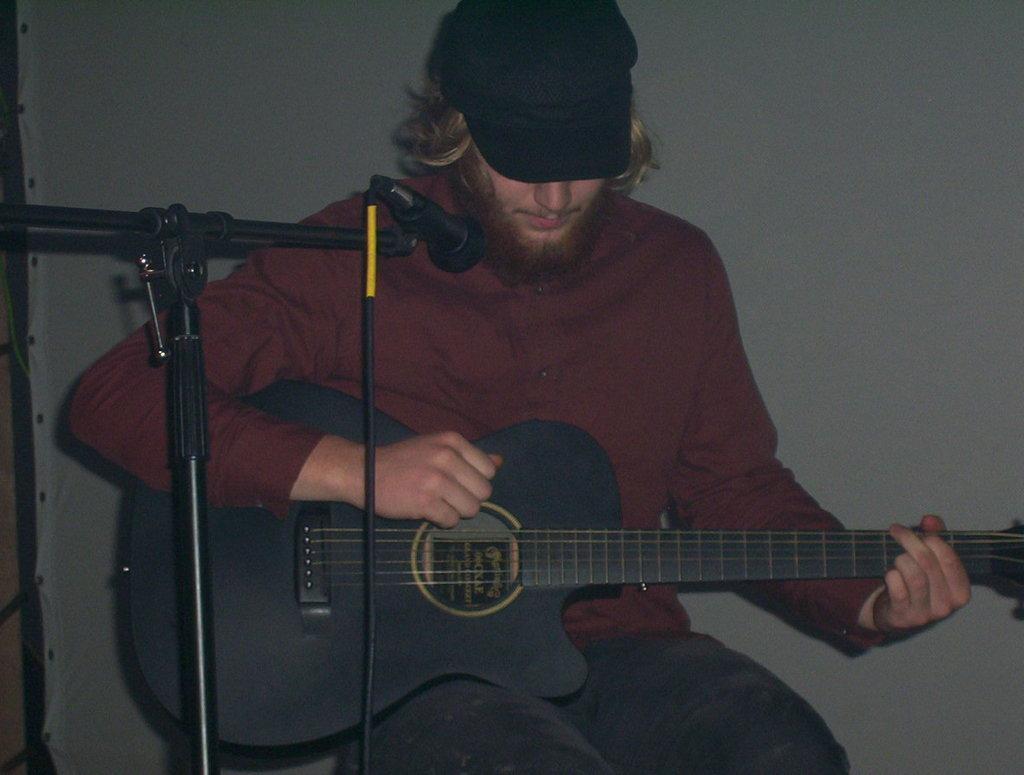How would you summarize this image in a sentence or two? In this image there is a man in the center sitting and holding a musical instrument. In front of the man there are mics and the man is wearing a black colour hat. In the background there is a white colour curtain. 